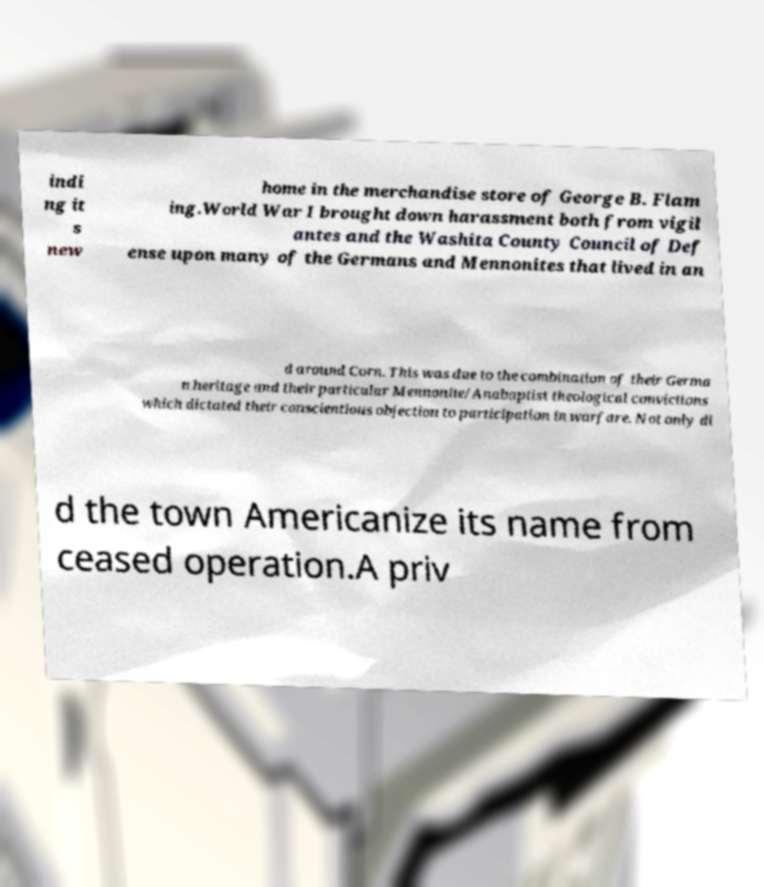Can you accurately transcribe the text from the provided image for me? indi ng it s new home in the merchandise store of George B. Flam ing.World War I brought down harassment both from vigil antes and the Washita County Council of Def ense upon many of the Germans and Mennonites that lived in an d around Corn. This was due to the combination of their Germa n heritage and their particular Mennonite/Anabaptist theological convictions which dictated their conscientious objection to participation in warfare. Not only di d the town Americanize its name from ceased operation.A priv 